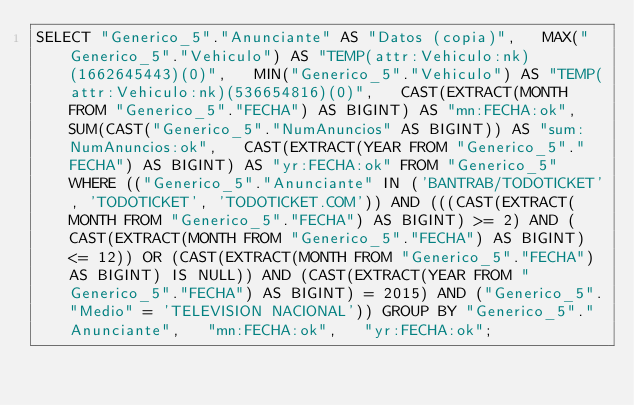<code> <loc_0><loc_0><loc_500><loc_500><_SQL_>SELECT "Generico_5"."Anunciante" AS "Datos (copia)",   MAX("Generico_5"."Vehiculo") AS "TEMP(attr:Vehiculo:nk)(1662645443)(0)",   MIN("Generico_5"."Vehiculo") AS "TEMP(attr:Vehiculo:nk)(536654816)(0)",   CAST(EXTRACT(MONTH FROM "Generico_5"."FECHA") AS BIGINT) AS "mn:FECHA:ok",   SUM(CAST("Generico_5"."NumAnuncios" AS BIGINT)) AS "sum:NumAnuncios:ok",   CAST(EXTRACT(YEAR FROM "Generico_5"."FECHA") AS BIGINT) AS "yr:FECHA:ok" FROM "Generico_5" WHERE (("Generico_5"."Anunciante" IN ('BANTRAB/TODOTICKET', 'TODOTICKET', 'TODOTICKET.COM')) AND (((CAST(EXTRACT(MONTH FROM "Generico_5"."FECHA") AS BIGINT) >= 2) AND (CAST(EXTRACT(MONTH FROM "Generico_5"."FECHA") AS BIGINT) <= 12)) OR (CAST(EXTRACT(MONTH FROM "Generico_5"."FECHA") AS BIGINT) IS NULL)) AND (CAST(EXTRACT(YEAR FROM "Generico_5"."FECHA") AS BIGINT) = 2015) AND ("Generico_5"."Medio" = 'TELEVISION NACIONAL')) GROUP BY "Generico_5"."Anunciante",   "mn:FECHA:ok",   "yr:FECHA:ok";
</code> 